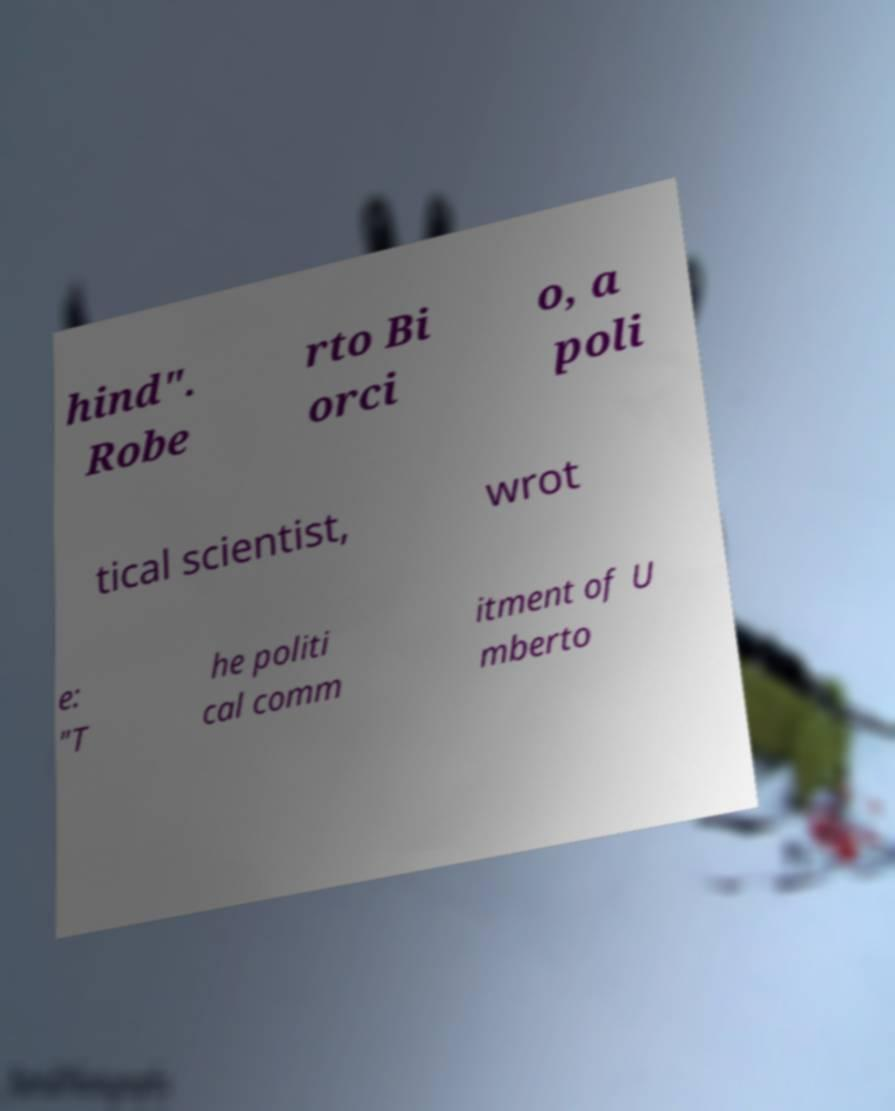Please identify and transcribe the text found in this image. hind". Robe rto Bi orci o, a poli tical scientist, wrot e: "T he politi cal comm itment of U mberto 